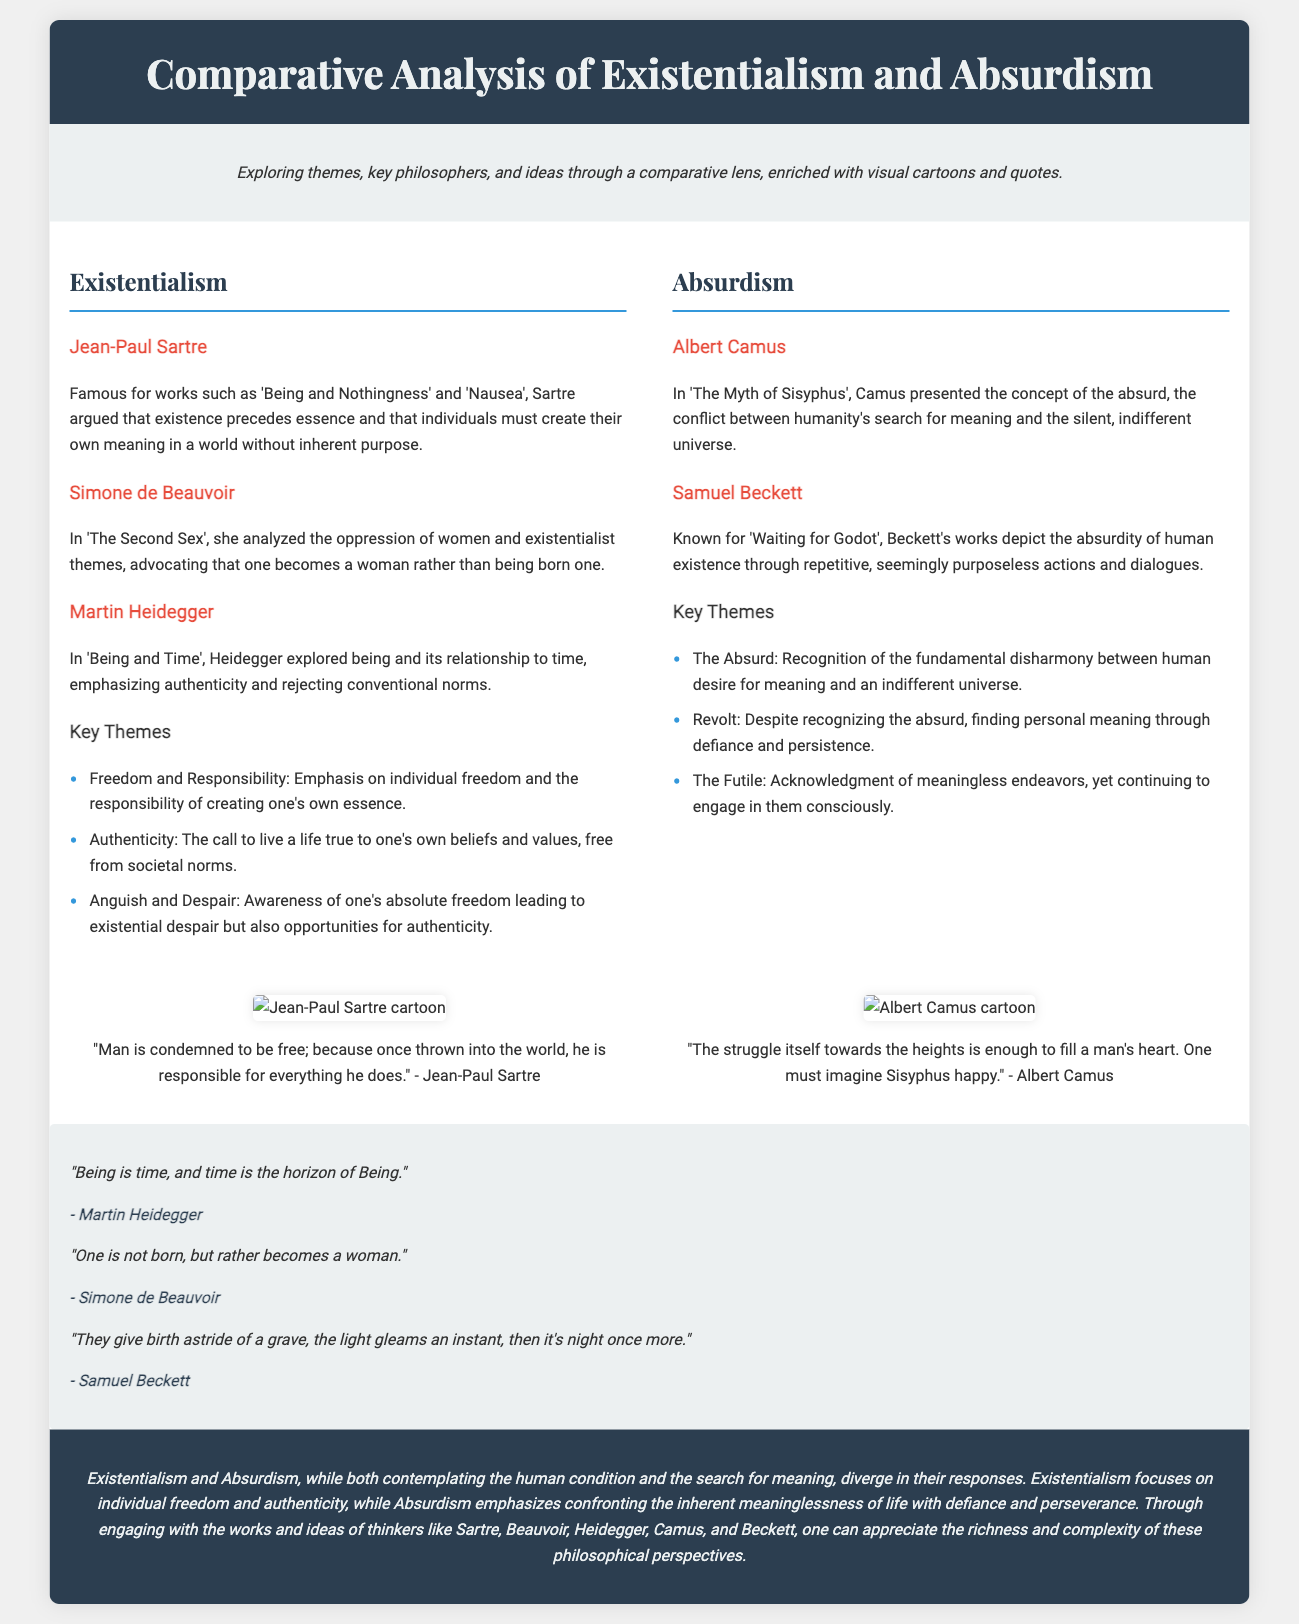What is the main title of the presentation? The main title is displayed prominently at the top of the document.
Answer: Comparative Analysis of Existentialism and Absurdism Who is the philosopher associated with the quote "One must imagine Sisyphus happy"? This quote is attributed to the philosopher discussed in the Absurdism section.
Answer: Albert Camus What are the three key themes of Absurdism? The document lists these themes under the Absurdism section.
Answer: The Absurd, Revolt, The Futile Which philosopher wrote "The Second Sex"? The philosopher who analyzed women's oppression and existentialist themes is credited with this work.
Answer: Simone de Beauvoir How many key philosophers are mentioned in the Existentialism section? By counting the entries in the Existentialism section, we can determine the number.
Answer: Three What theme emphasizes the individual’s freedom and responsibility? This theme is highlighted in the Existentialism section, showcasing a central idea of the philosophy.
Answer: Freedom and Responsibility What visual elements accompany the quotes in the presentation? The document mentions specific formatting that accompanies quotes, such as images.
Answer: Visual cartoons In which section is Martin Heidegger discussed? The philosopher is mentioned as part of a prominent philosophical movement characterized in the presentation.
Answer: Existentialism What philosophical concept is central to Jean-Paul Sartre's works? This concept is fundamental to Sartre’s philosophical viewpoint as highlighted in the document.
Answer: Existence precedes essence 